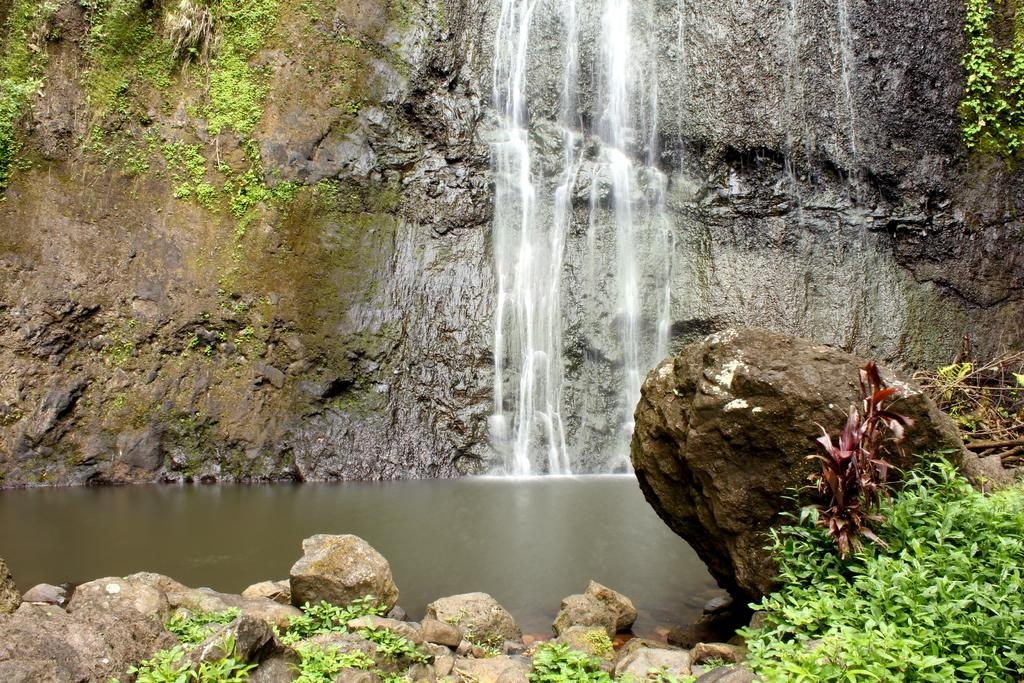What type of natural elements can be seen in the image? There are plants and rocks visible in the image. What is the main feature of the image? There is a waterfall in the image. What can be seen in the distance in the image? Hills are visible in the background of the image. What type of canvas is used to create the waterfall in the image? The image is a photograph and does not involve a canvas. The waterfall is a natural feature, not a painted or drawn representation. 